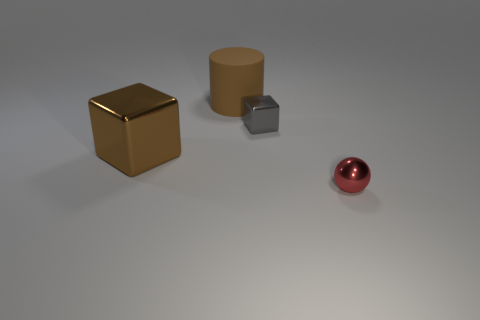There is a brown rubber cylinder that is right of the metallic block that is on the left side of the gray block; is there a tiny red metal sphere that is left of it?
Provide a succinct answer. No. What color is the tiny metal cube?
Give a very brief answer. Gray. There is a metal object that is on the right side of the tiny shiny cube; does it have the same shape as the large metal object?
Ensure brevity in your answer.  No. What number of objects are either large brown cylinders or small metal objects in front of the big brown shiny cube?
Your response must be concise. 2. Do the large object that is on the left side of the big brown rubber thing and the big cylinder have the same material?
Give a very brief answer. No. There is a brown thing that is to the left of the large object behind the tiny gray shiny object; what is its material?
Ensure brevity in your answer.  Metal. Is the number of things behind the big brown shiny thing greater than the number of large blocks that are behind the big cylinder?
Provide a short and direct response. Yes. How big is the red metallic ball?
Your answer should be compact. Small. There is a large thing left of the brown matte thing; does it have the same color as the rubber thing?
Offer a very short reply. Yes. Is there any other thing that is the same shape as the rubber object?
Your answer should be compact. No. 